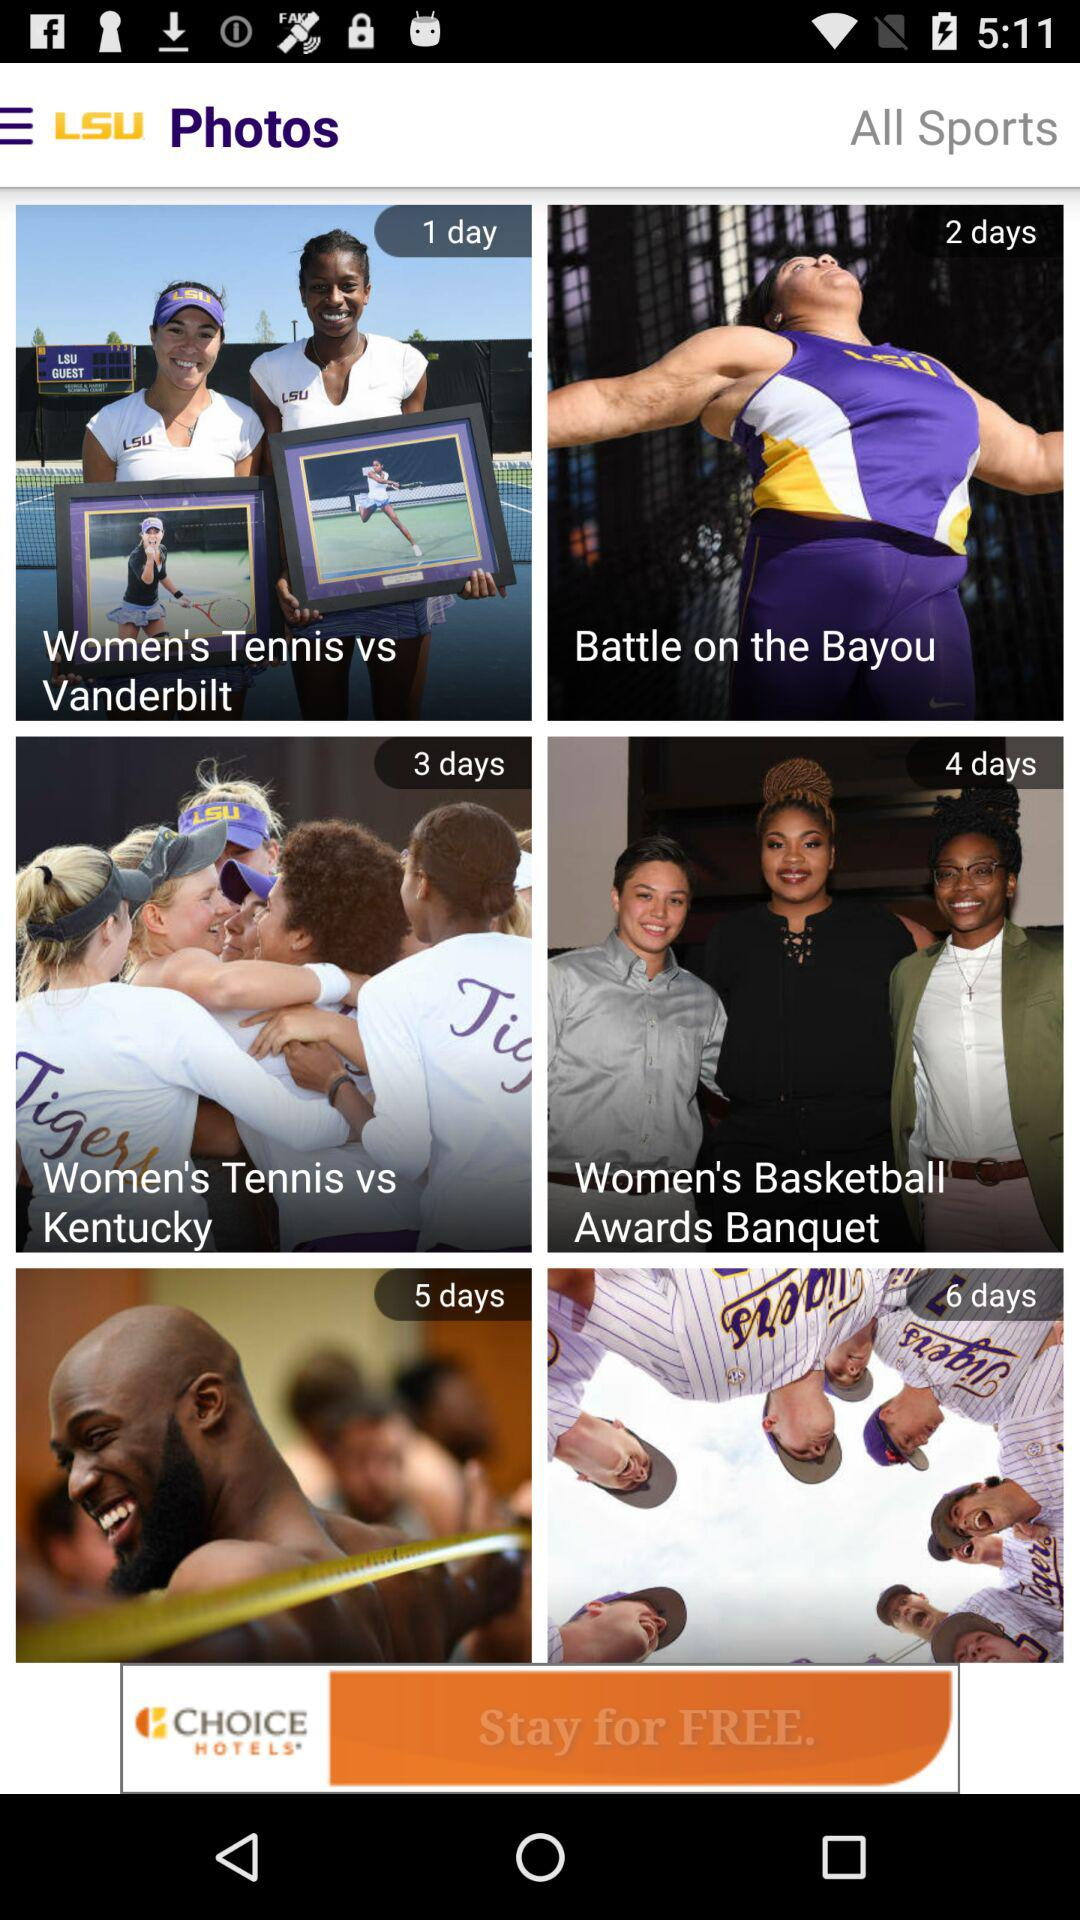When was the photo "Women's Tennis vs Vanderbilt" posted? The photo was posted on 1 day. 